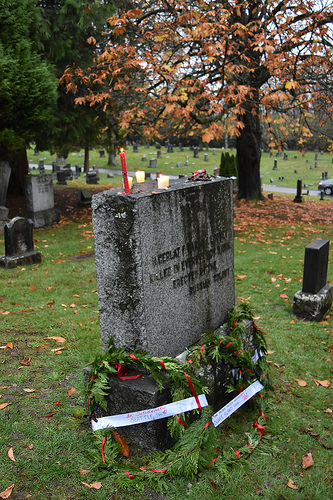<image>
Can you confirm if the candle is in front of the tree? Yes. The candle is positioned in front of the tree, appearing closer to the camera viewpoint. 